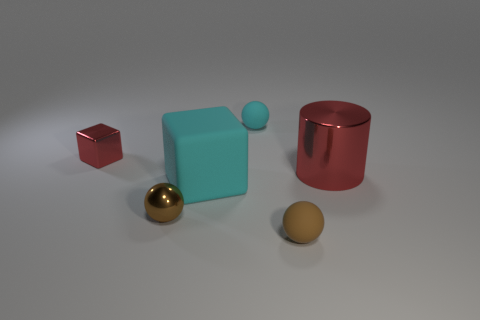Add 2 gray rubber cylinders. How many objects exist? 8 Subtract all cylinders. How many objects are left? 5 Subtract 0 gray cylinders. How many objects are left? 6 Subtract all big red cylinders. Subtract all red blocks. How many objects are left? 4 Add 4 small red blocks. How many small red blocks are left? 5 Add 5 cylinders. How many cylinders exist? 6 